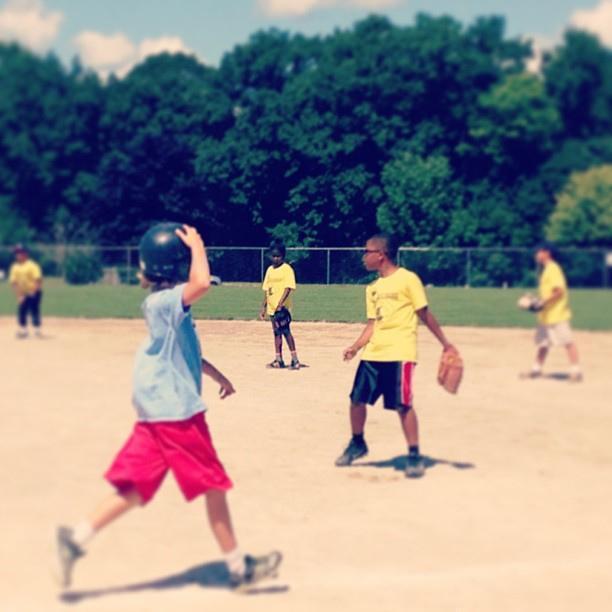What color are the shorts on the boy wearing a baseball helmet?
From the following four choices, select the correct answer to address the question.
Options: Black, yellow, red, blue. Red. 